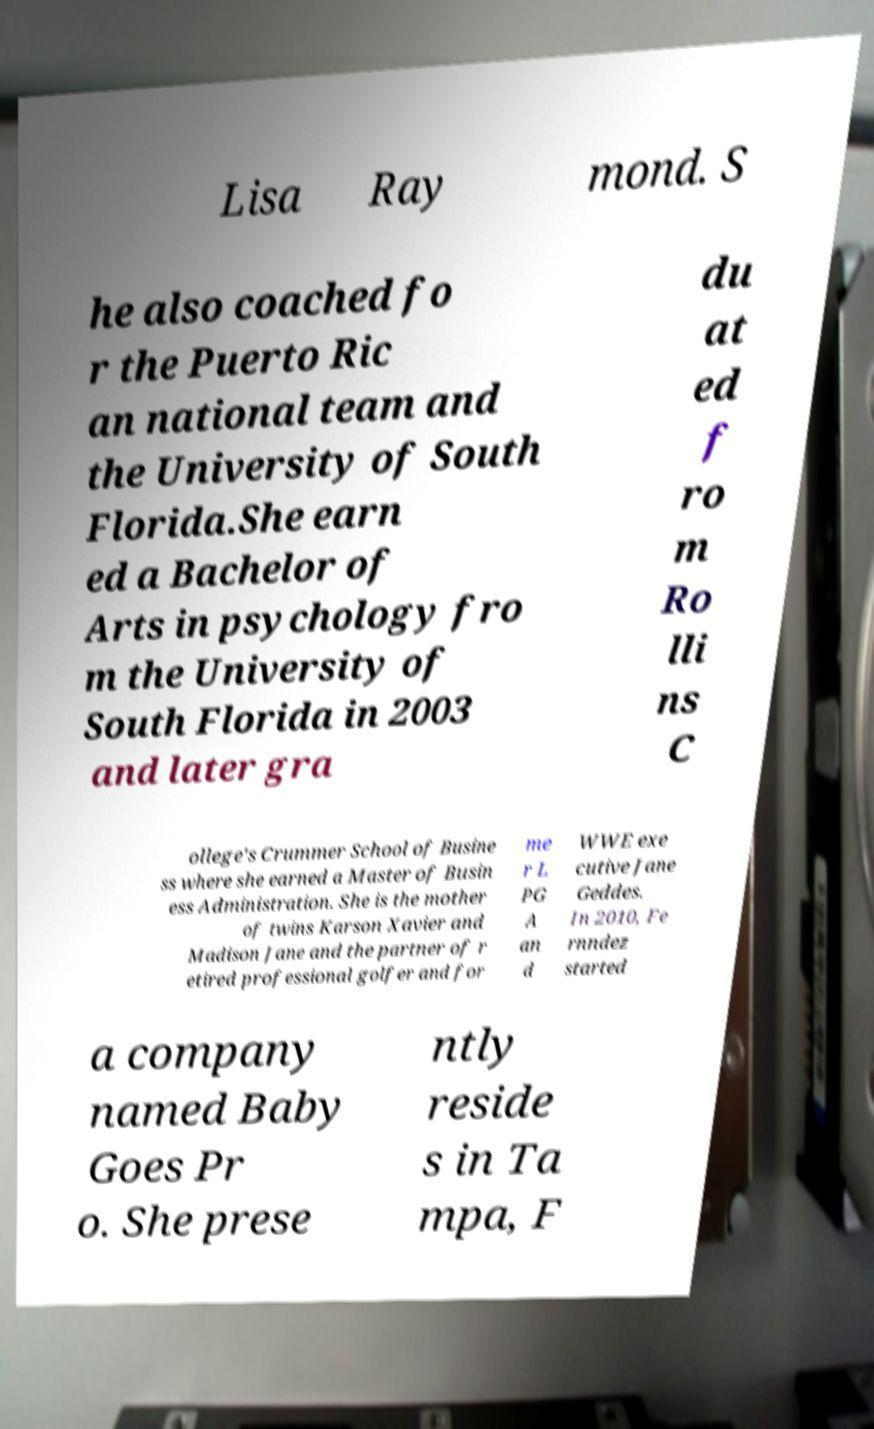Can you read and provide the text displayed in the image?This photo seems to have some interesting text. Can you extract and type it out for me? Lisa Ray mond. S he also coached fo r the Puerto Ric an national team and the University of South Florida.She earn ed a Bachelor of Arts in psychology fro m the University of South Florida in 2003 and later gra du at ed f ro m Ro lli ns C ollege's Crummer School of Busine ss where she earned a Master of Busin ess Administration. She is the mother of twins Karson Xavier and Madison Jane and the partner of r etired professional golfer and for me r L PG A an d WWE exe cutive Jane Geddes. In 2010, Fe rnndez started a company named Baby Goes Pr o. She prese ntly reside s in Ta mpa, F 